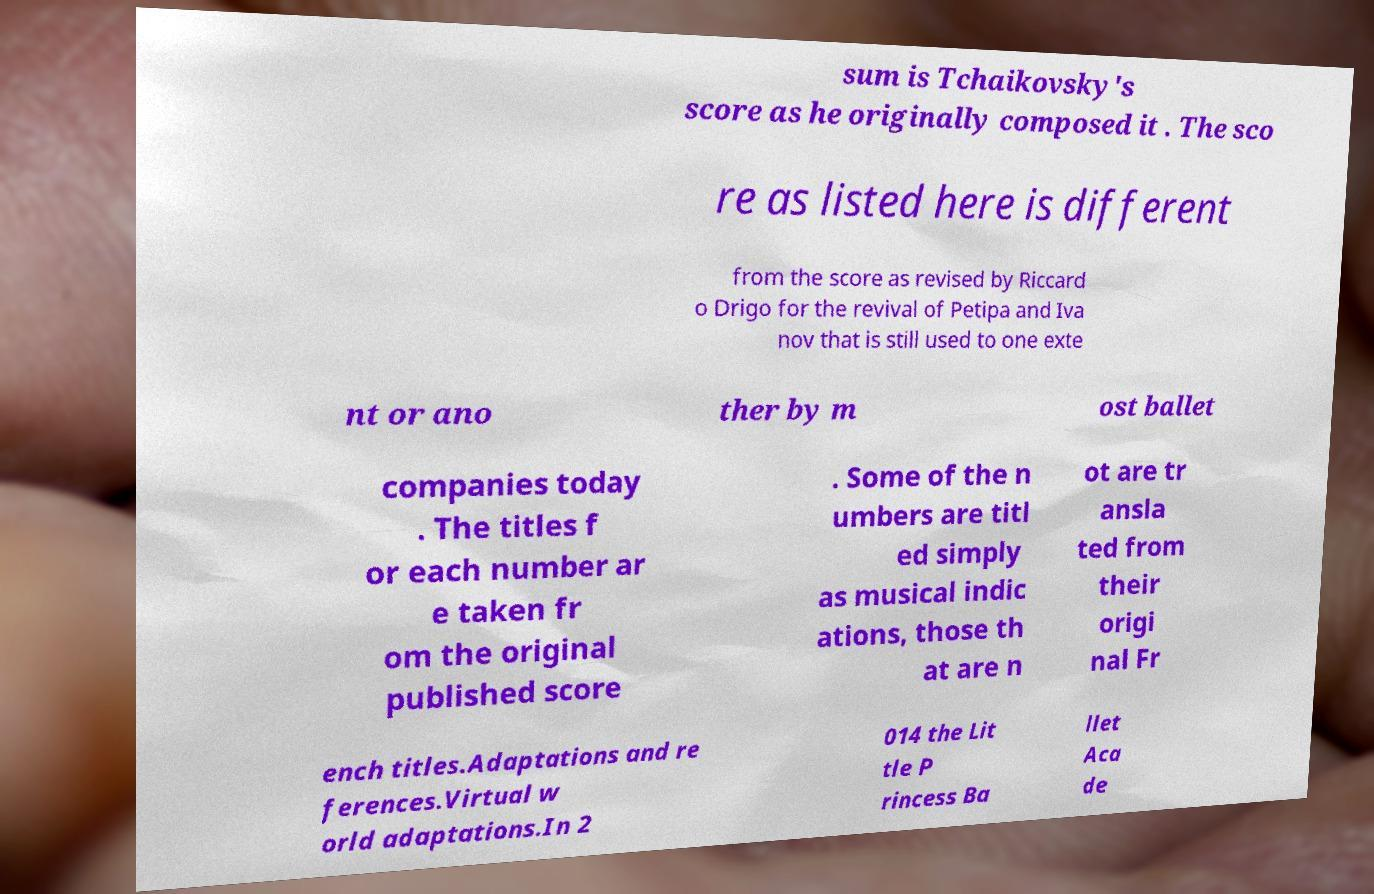For documentation purposes, I need the text within this image transcribed. Could you provide that? sum is Tchaikovsky's score as he originally composed it . The sco re as listed here is different from the score as revised by Riccard o Drigo for the revival of Petipa and Iva nov that is still used to one exte nt or ano ther by m ost ballet companies today . The titles f or each number ar e taken fr om the original published score . Some of the n umbers are titl ed simply as musical indic ations, those th at are n ot are tr ansla ted from their origi nal Fr ench titles.Adaptations and re ferences.Virtual w orld adaptations.In 2 014 the Lit tle P rincess Ba llet Aca de 